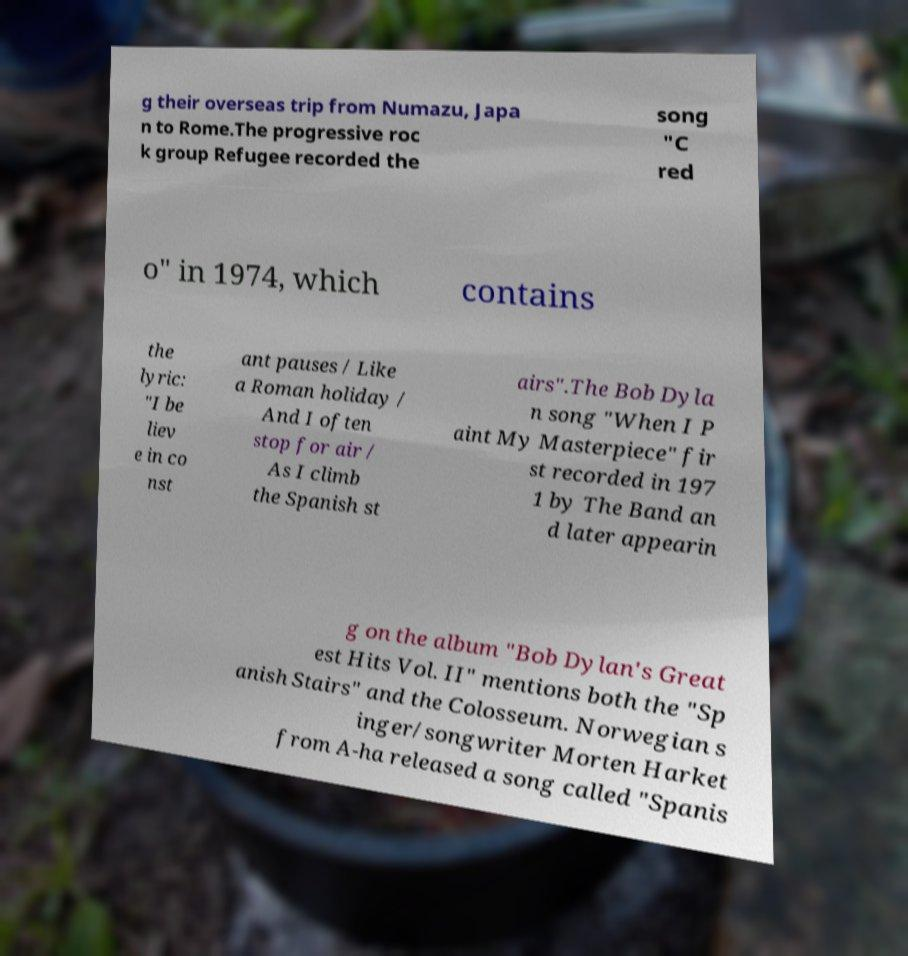Please read and relay the text visible in this image. What does it say? g their overseas trip from Numazu, Japa n to Rome.The progressive roc k group Refugee recorded the song "C red o" in 1974, which contains the lyric: "I be liev e in co nst ant pauses / Like a Roman holiday / And I often stop for air / As I climb the Spanish st airs".The Bob Dyla n song "When I P aint My Masterpiece" fir st recorded in 197 1 by The Band an d later appearin g on the album "Bob Dylan's Great est Hits Vol. II" mentions both the "Sp anish Stairs" and the Colosseum. Norwegian s inger/songwriter Morten Harket from A-ha released a song called "Spanis 